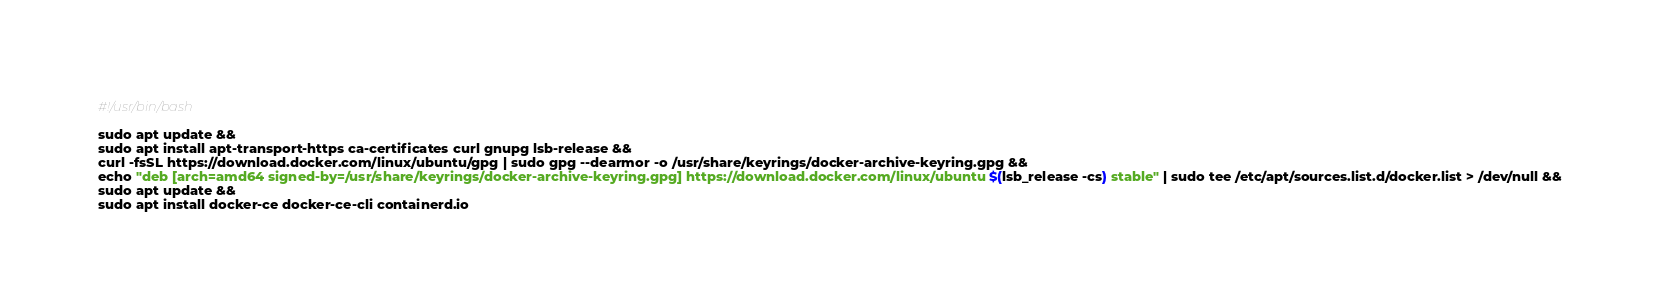Convert code to text. <code><loc_0><loc_0><loc_500><loc_500><_Bash_>#!/usr/bin/bash

sudo apt update &&
sudo apt install apt-transport-https ca-certificates curl gnupg lsb-release &&
curl -fsSL https://download.docker.com/linux/ubuntu/gpg | sudo gpg --dearmor -o /usr/share/keyrings/docker-archive-keyring.gpg &&
echo "deb [arch=amd64 signed-by=/usr/share/keyrings/docker-archive-keyring.gpg] https://download.docker.com/linux/ubuntu $(lsb_release -cs) stable" | sudo tee /etc/apt/sources.list.d/docker.list > /dev/null &&
sudo apt update &&
sudo apt install docker-ce docker-ce-cli containerd.io
</code> 